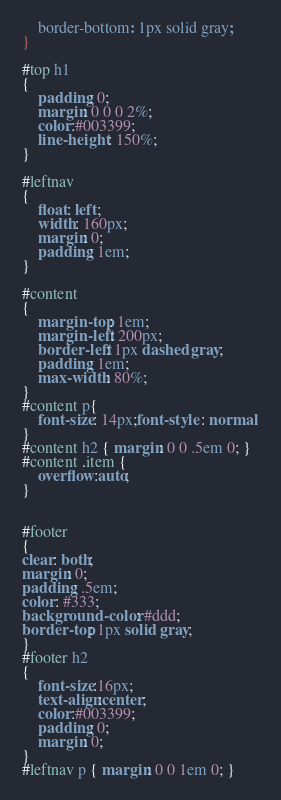<code> <loc_0><loc_0><loc_500><loc_500><_CSS_>	border-bottom: 1px solid gray;
}

#top h1
{
	padding: 0;
	margin: 0 0 0 2%;
	color:#003399;
	line-height: 150%;
}

#leftnav
{
	float: left;
	width: 160px;
	margin: 0;
	padding: 1em;
}

#content
{
	margin-top: 1em;
	margin-left: 200px;
	border-left: 1px dashed gray;
	padding: 1em;
	max-width: 80%;
}
#content p{
	font-size: 14px;font-style : normal 
}
#content h2 { margin: 0 0 .5em 0; }
#content .item {
	overflow:auto;
}


#footer
{
clear: both;
margin: 0;
padding: .5em;
color: #333;
background-color: #ddd;
border-top: 1px solid gray;
}
#footer h2
{
	font-size:16px;
	text-align:center;
	color:#003399;
	padding: 0;
	margin: 0;
}
#leftnav p { margin: 0 0 1em 0; }
</code> 